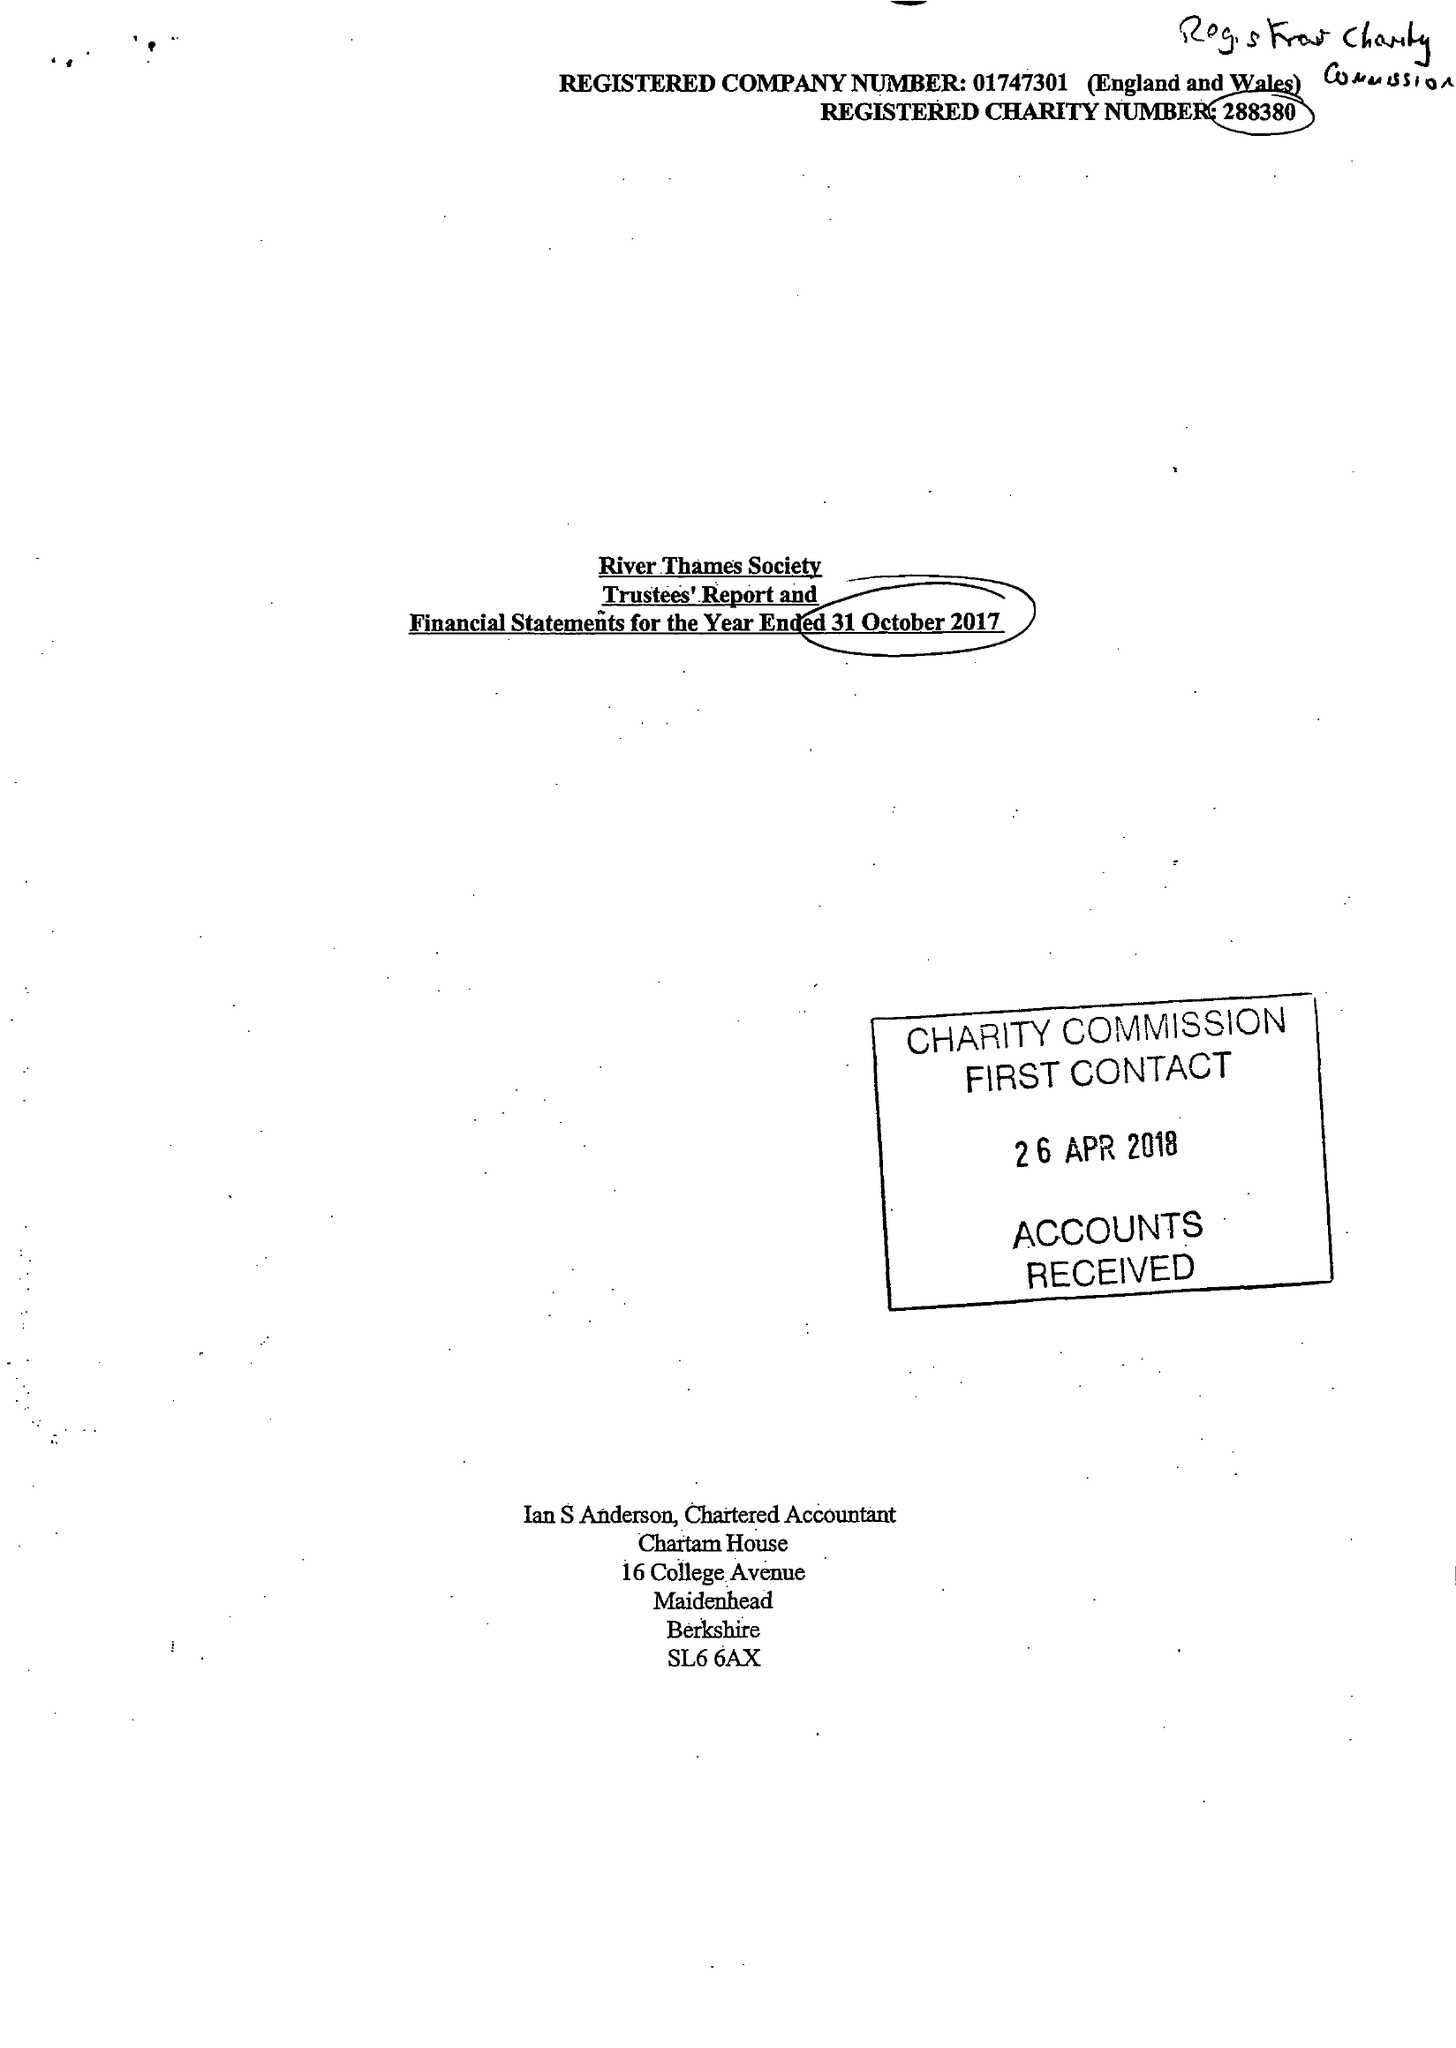What is the value for the spending_annually_in_british_pounds?
Answer the question using a single word or phrase. 33646.00 